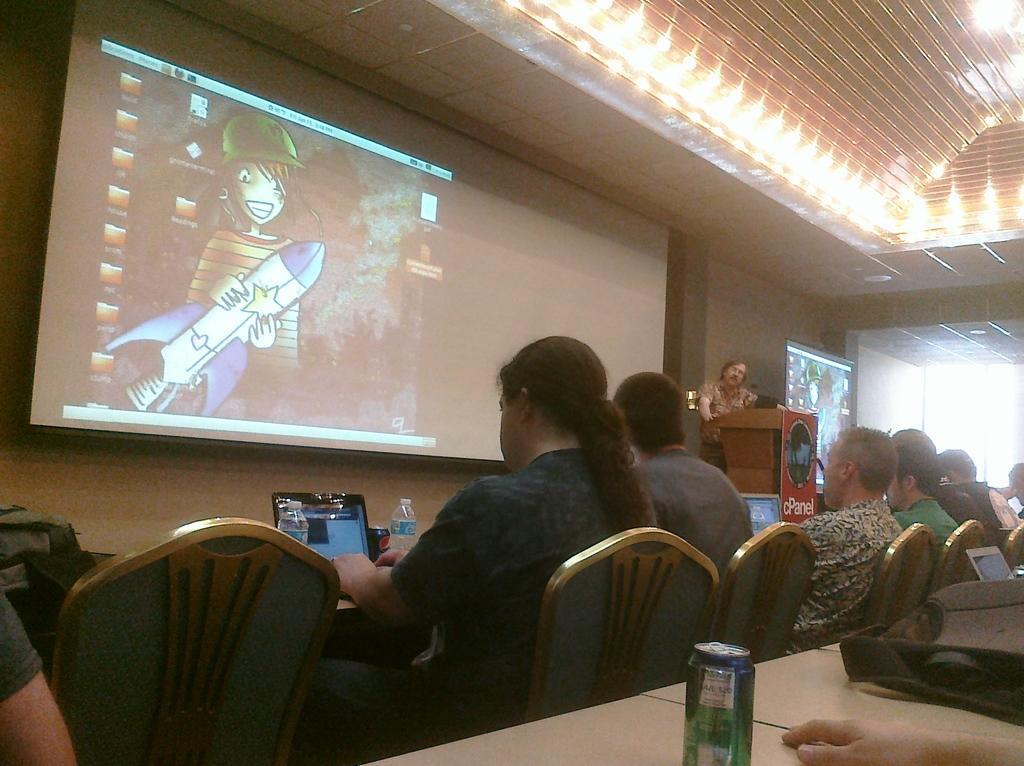What is the main object in the image? There is a screen in the image. What are the people in the image doing? The people are sitting on chairs in the image. What other furniture is present in the image? There is a table in the image. What items can be seen on the table? There is a bag, a tin, and a laptop on the table. How does the crowd react to the sound of the bell in the image? There is no crowd, bell, or any sound mentioned in the image. The image only shows a screen, people sitting on chairs, a table, and items on the table. 